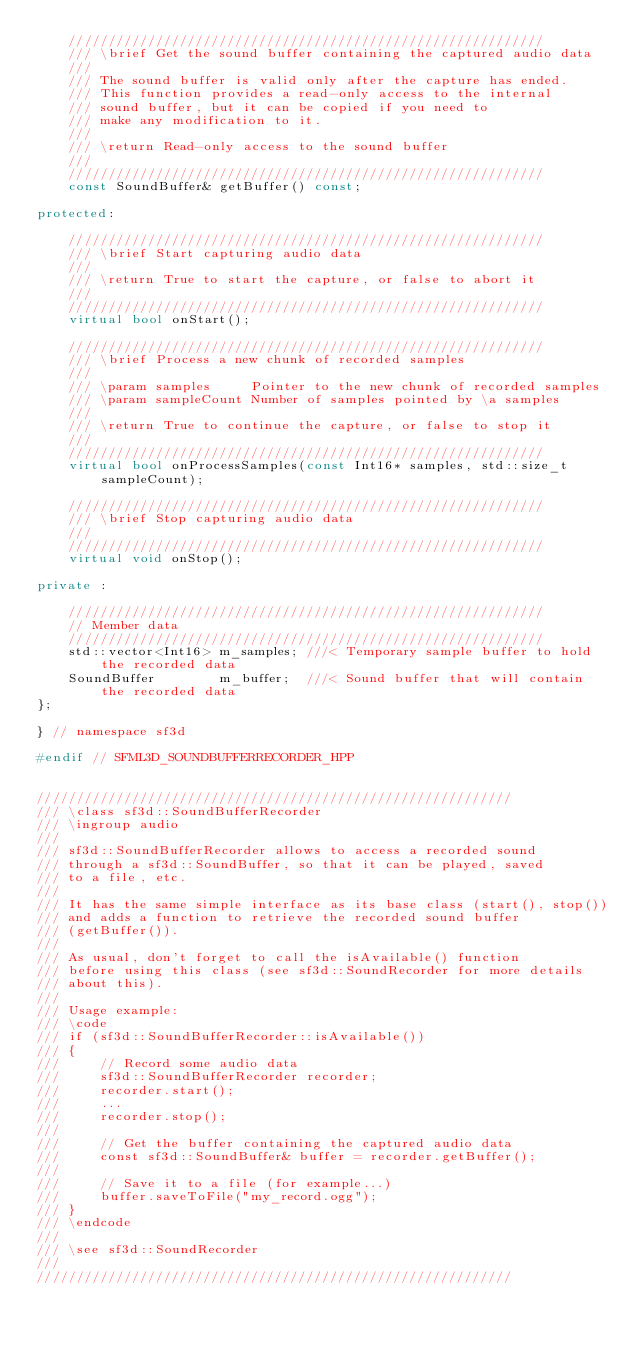Convert code to text. <code><loc_0><loc_0><loc_500><loc_500><_C++_>    ////////////////////////////////////////////////////////////
    /// \brief Get the sound buffer containing the captured audio data
    ///
    /// The sound buffer is valid only after the capture has ended.
    /// This function provides a read-only access to the internal
    /// sound buffer, but it can be copied if you need to
    /// make any modification to it.
    ///
    /// \return Read-only access to the sound buffer
    ///
    ////////////////////////////////////////////////////////////
    const SoundBuffer& getBuffer() const;

protected:

    ////////////////////////////////////////////////////////////
    /// \brief Start capturing audio data
    ///
    /// \return True to start the capture, or false to abort it
    ///
    ////////////////////////////////////////////////////////////
    virtual bool onStart();

    ////////////////////////////////////////////////////////////
    /// \brief Process a new chunk of recorded samples
    ///
    /// \param samples     Pointer to the new chunk of recorded samples
    /// \param sampleCount Number of samples pointed by \a samples
    ///
    /// \return True to continue the capture, or false to stop it
    ///
    ////////////////////////////////////////////////////////////
    virtual bool onProcessSamples(const Int16* samples, std::size_t sampleCount);

    ////////////////////////////////////////////////////////////
    /// \brief Stop capturing audio data
    ///
    ////////////////////////////////////////////////////////////
    virtual void onStop();

private :

    ////////////////////////////////////////////////////////////
    // Member data
    ////////////////////////////////////////////////////////////
    std::vector<Int16> m_samples; ///< Temporary sample buffer to hold the recorded data
    SoundBuffer        m_buffer;  ///< Sound buffer that will contain the recorded data
};

} // namespace sf3d

#endif // SFML3D_SOUNDBUFFERRECORDER_HPP


////////////////////////////////////////////////////////////
/// \class sf3d::SoundBufferRecorder
/// \ingroup audio
///
/// sf3d::SoundBufferRecorder allows to access a recorded sound
/// through a sf3d::SoundBuffer, so that it can be played, saved
/// to a file, etc.
///
/// It has the same simple interface as its base class (start(), stop())
/// and adds a function to retrieve the recorded sound buffer
/// (getBuffer()).
///
/// As usual, don't forget to call the isAvailable() function
/// before using this class (see sf3d::SoundRecorder for more details
/// about this).
///
/// Usage example:
/// \code
/// if (sf3d::SoundBufferRecorder::isAvailable())
/// {
///     // Record some audio data
///     sf3d::SoundBufferRecorder recorder;
///     recorder.start();
///     ...
///     recorder.stop();
///
///     // Get the buffer containing the captured audio data
///     const sf3d::SoundBuffer& buffer = recorder.getBuffer();
///
///     // Save it to a file (for example...)
///     buffer.saveToFile("my_record.ogg");
/// }
/// \endcode
///
/// \see sf3d::SoundRecorder
///
////////////////////////////////////////////////////////////
</code> 